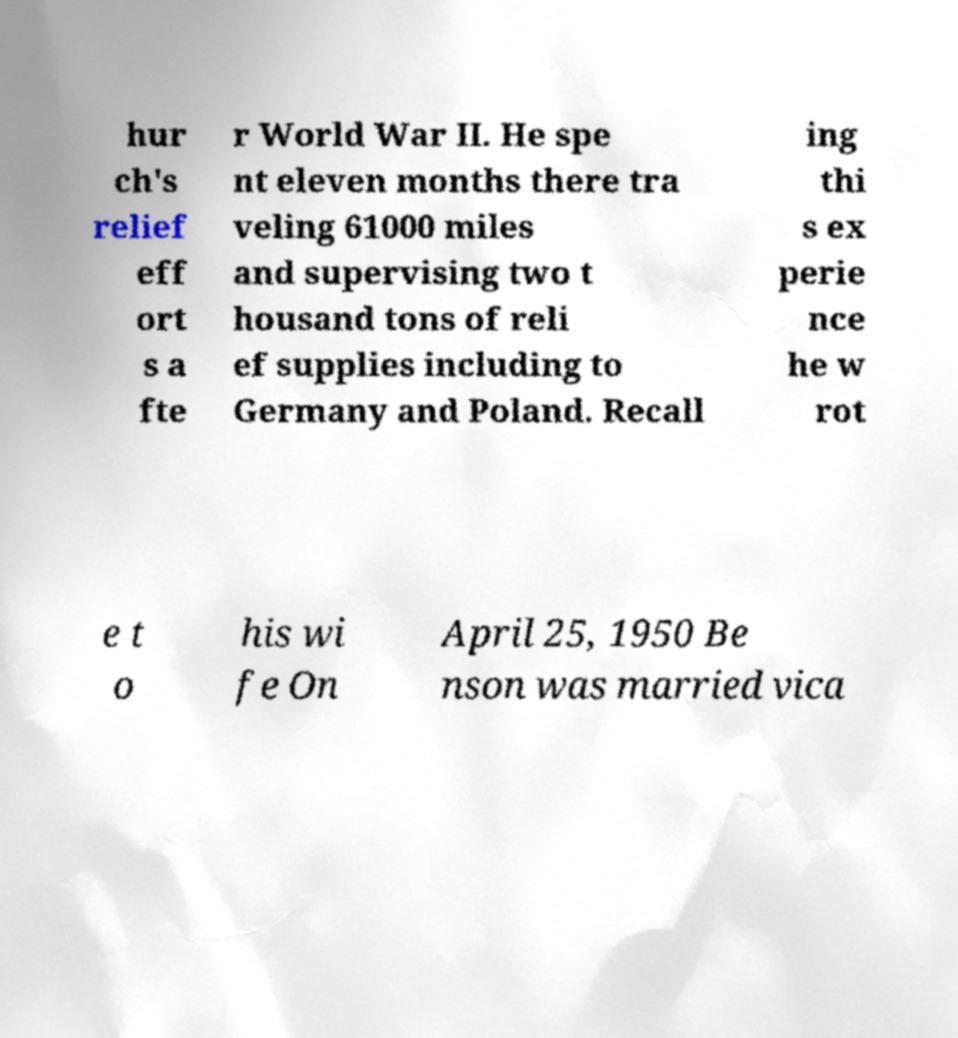Can you read and provide the text displayed in the image?This photo seems to have some interesting text. Can you extract and type it out for me? hur ch's relief eff ort s a fte r World War II. He spe nt eleven months there tra veling 61000 miles and supervising two t housand tons of reli ef supplies including to Germany and Poland. Recall ing thi s ex perie nce he w rot e t o his wi fe On April 25, 1950 Be nson was married vica 